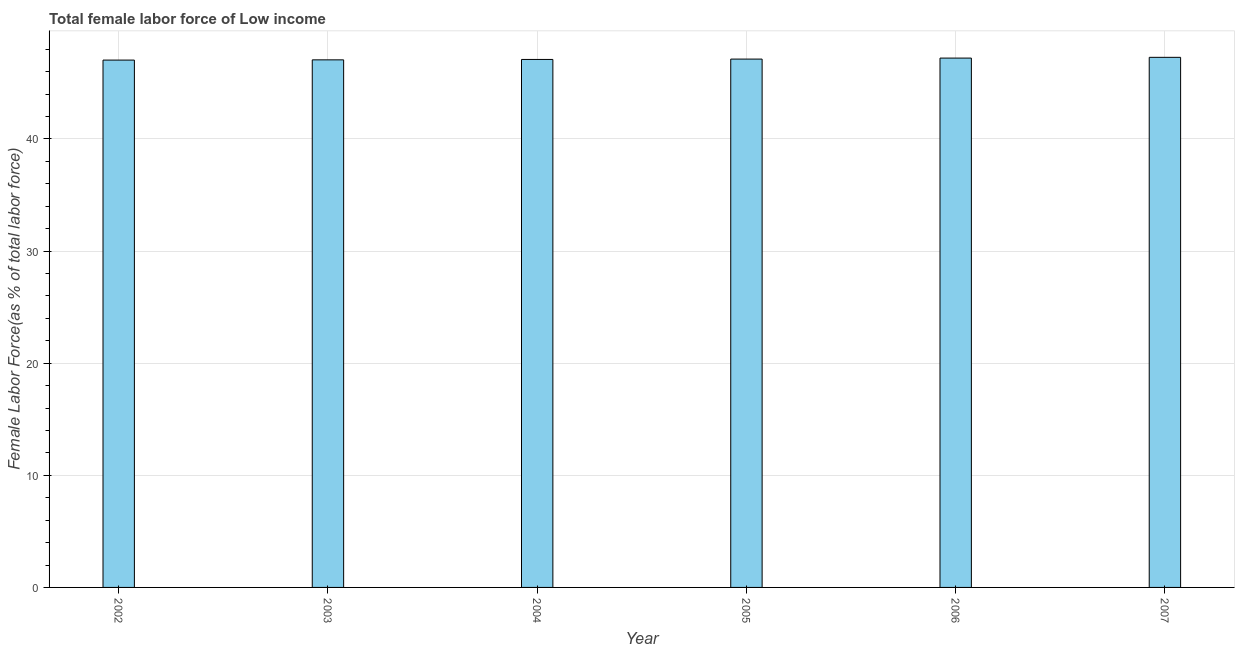Does the graph contain any zero values?
Provide a short and direct response. No. What is the title of the graph?
Your answer should be compact. Total female labor force of Low income. What is the label or title of the X-axis?
Ensure brevity in your answer.  Year. What is the label or title of the Y-axis?
Offer a very short reply. Female Labor Force(as % of total labor force). What is the total female labor force in 2005?
Your response must be concise. 47.13. Across all years, what is the maximum total female labor force?
Your answer should be compact. 47.28. Across all years, what is the minimum total female labor force?
Your answer should be very brief. 47.04. In which year was the total female labor force maximum?
Ensure brevity in your answer.  2007. In which year was the total female labor force minimum?
Make the answer very short. 2002. What is the sum of the total female labor force?
Provide a succinct answer. 282.83. What is the difference between the total female labor force in 2002 and 2006?
Offer a terse response. -0.18. What is the average total female labor force per year?
Provide a succinct answer. 47.14. What is the median total female labor force?
Provide a succinct answer. 47.11. Do a majority of the years between 2002 and 2003 (inclusive) have total female labor force greater than 6 %?
Offer a very short reply. Yes. What is the ratio of the total female labor force in 2002 to that in 2006?
Make the answer very short. 1. Is the total female labor force in 2005 less than that in 2006?
Your response must be concise. Yes. Is the difference between the total female labor force in 2002 and 2006 greater than the difference between any two years?
Provide a short and direct response. No. What is the difference between the highest and the second highest total female labor force?
Ensure brevity in your answer.  0.07. Is the sum of the total female labor force in 2003 and 2004 greater than the maximum total female labor force across all years?
Your response must be concise. Yes. What is the difference between the highest and the lowest total female labor force?
Your response must be concise. 0.25. How many bars are there?
Offer a very short reply. 6. Are all the bars in the graph horizontal?
Provide a short and direct response. No. How many years are there in the graph?
Give a very brief answer. 6. Are the values on the major ticks of Y-axis written in scientific E-notation?
Give a very brief answer. No. What is the Female Labor Force(as % of total labor force) in 2002?
Give a very brief answer. 47.04. What is the Female Labor Force(as % of total labor force) in 2003?
Provide a succinct answer. 47.06. What is the Female Labor Force(as % of total labor force) of 2004?
Ensure brevity in your answer.  47.1. What is the Female Labor Force(as % of total labor force) of 2005?
Make the answer very short. 47.13. What is the Female Labor Force(as % of total labor force) of 2006?
Ensure brevity in your answer.  47.22. What is the Female Labor Force(as % of total labor force) of 2007?
Provide a succinct answer. 47.28. What is the difference between the Female Labor Force(as % of total labor force) in 2002 and 2003?
Offer a terse response. -0.02. What is the difference between the Female Labor Force(as % of total labor force) in 2002 and 2004?
Offer a terse response. -0.06. What is the difference between the Female Labor Force(as % of total labor force) in 2002 and 2005?
Your answer should be very brief. -0.09. What is the difference between the Female Labor Force(as % of total labor force) in 2002 and 2006?
Make the answer very short. -0.18. What is the difference between the Female Labor Force(as % of total labor force) in 2002 and 2007?
Offer a very short reply. -0.25. What is the difference between the Female Labor Force(as % of total labor force) in 2003 and 2004?
Keep it short and to the point. -0.04. What is the difference between the Female Labor Force(as % of total labor force) in 2003 and 2005?
Make the answer very short. -0.07. What is the difference between the Female Labor Force(as % of total labor force) in 2003 and 2006?
Provide a succinct answer. -0.16. What is the difference between the Female Labor Force(as % of total labor force) in 2003 and 2007?
Make the answer very short. -0.23. What is the difference between the Female Labor Force(as % of total labor force) in 2004 and 2005?
Make the answer very short. -0.03. What is the difference between the Female Labor Force(as % of total labor force) in 2004 and 2006?
Your answer should be compact. -0.12. What is the difference between the Female Labor Force(as % of total labor force) in 2004 and 2007?
Make the answer very short. -0.19. What is the difference between the Female Labor Force(as % of total labor force) in 2005 and 2006?
Your answer should be very brief. -0.09. What is the difference between the Female Labor Force(as % of total labor force) in 2005 and 2007?
Your answer should be compact. -0.16. What is the difference between the Female Labor Force(as % of total labor force) in 2006 and 2007?
Your answer should be very brief. -0.07. What is the ratio of the Female Labor Force(as % of total labor force) in 2002 to that in 2003?
Ensure brevity in your answer.  1. What is the ratio of the Female Labor Force(as % of total labor force) in 2002 to that in 2005?
Ensure brevity in your answer.  1. What is the ratio of the Female Labor Force(as % of total labor force) in 2002 to that in 2006?
Your answer should be very brief. 1. What is the ratio of the Female Labor Force(as % of total labor force) in 2002 to that in 2007?
Your answer should be very brief. 0.99. What is the ratio of the Female Labor Force(as % of total labor force) in 2003 to that in 2004?
Ensure brevity in your answer.  1. What is the ratio of the Female Labor Force(as % of total labor force) in 2003 to that in 2005?
Give a very brief answer. 1. What is the ratio of the Female Labor Force(as % of total labor force) in 2004 to that in 2005?
Your answer should be very brief. 1. What is the ratio of the Female Labor Force(as % of total labor force) in 2004 to that in 2006?
Offer a terse response. 1. What is the ratio of the Female Labor Force(as % of total labor force) in 2004 to that in 2007?
Give a very brief answer. 1. What is the ratio of the Female Labor Force(as % of total labor force) in 2005 to that in 2007?
Give a very brief answer. 1. 